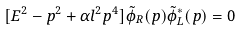<formula> <loc_0><loc_0><loc_500><loc_500>[ E ^ { 2 } - p ^ { 2 } + \alpha l ^ { 2 } p ^ { 4 } ] \tilde { \phi } _ { R } ( p ) \tilde { \phi } ^ { * } _ { L } ( p ) = 0</formula> 